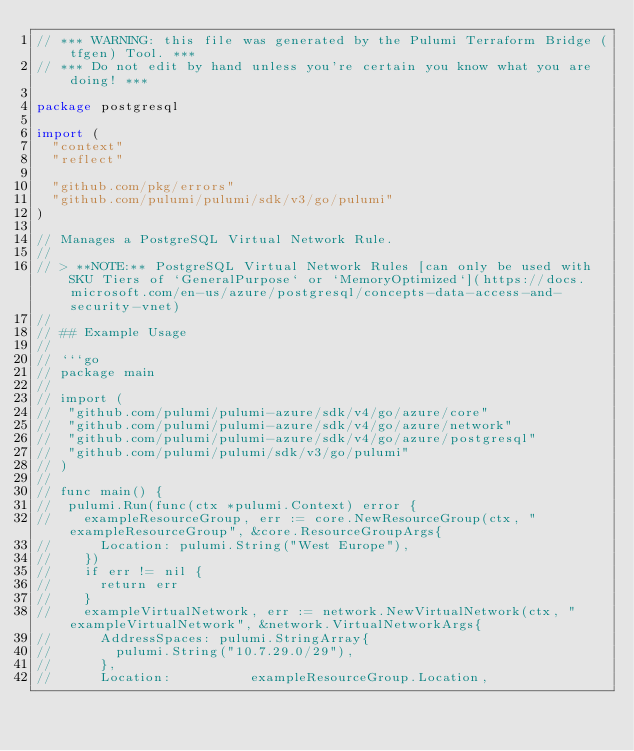<code> <loc_0><loc_0><loc_500><loc_500><_Go_>// *** WARNING: this file was generated by the Pulumi Terraform Bridge (tfgen) Tool. ***
// *** Do not edit by hand unless you're certain you know what you are doing! ***

package postgresql

import (
	"context"
	"reflect"

	"github.com/pkg/errors"
	"github.com/pulumi/pulumi/sdk/v3/go/pulumi"
)

// Manages a PostgreSQL Virtual Network Rule.
//
// > **NOTE:** PostgreSQL Virtual Network Rules [can only be used with SKU Tiers of `GeneralPurpose` or `MemoryOptimized`](https://docs.microsoft.com/en-us/azure/postgresql/concepts-data-access-and-security-vnet)
//
// ## Example Usage
//
// ```go
// package main
//
// import (
// 	"github.com/pulumi/pulumi-azure/sdk/v4/go/azure/core"
// 	"github.com/pulumi/pulumi-azure/sdk/v4/go/azure/network"
// 	"github.com/pulumi/pulumi-azure/sdk/v4/go/azure/postgresql"
// 	"github.com/pulumi/pulumi/sdk/v3/go/pulumi"
// )
//
// func main() {
// 	pulumi.Run(func(ctx *pulumi.Context) error {
// 		exampleResourceGroup, err := core.NewResourceGroup(ctx, "exampleResourceGroup", &core.ResourceGroupArgs{
// 			Location: pulumi.String("West Europe"),
// 		})
// 		if err != nil {
// 			return err
// 		}
// 		exampleVirtualNetwork, err := network.NewVirtualNetwork(ctx, "exampleVirtualNetwork", &network.VirtualNetworkArgs{
// 			AddressSpaces: pulumi.StringArray{
// 				pulumi.String("10.7.29.0/29"),
// 			},
// 			Location:          exampleResourceGroup.Location,</code> 